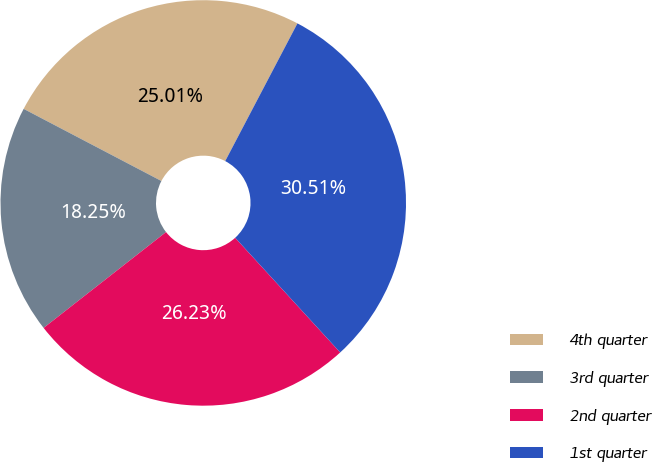Convert chart. <chart><loc_0><loc_0><loc_500><loc_500><pie_chart><fcel>4th quarter<fcel>3rd quarter<fcel>2nd quarter<fcel>1st quarter<nl><fcel>25.01%<fcel>18.25%<fcel>26.23%<fcel>30.51%<nl></chart> 